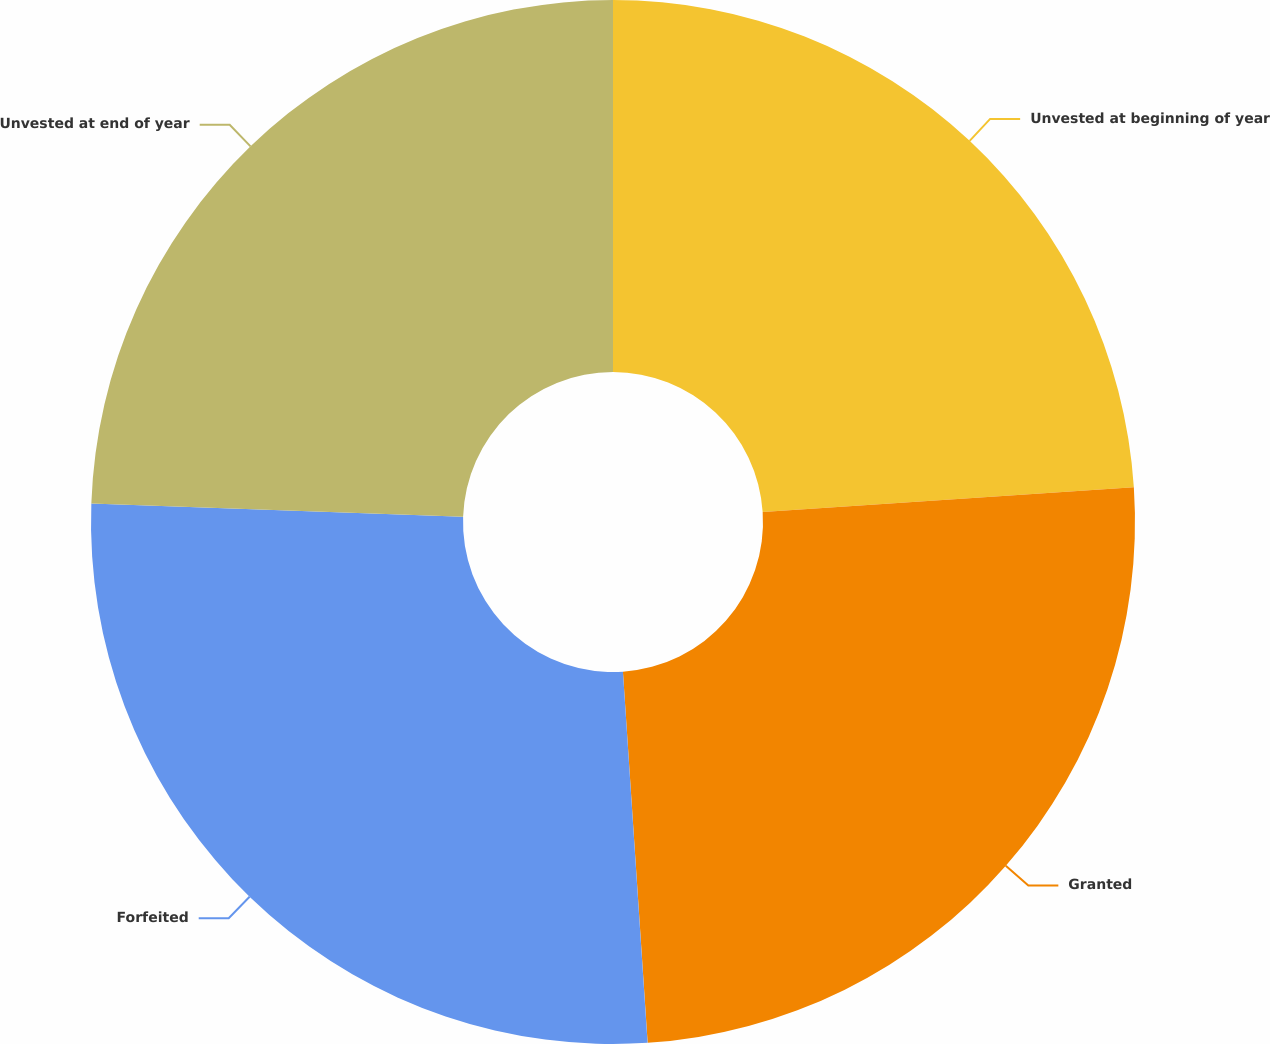Convert chart to OTSL. <chart><loc_0><loc_0><loc_500><loc_500><pie_chart><fcel>Unvested at beginning of year<fcel>Granted<fcel>Forfeited<fcel>Unvested at end of year<nl><fcel>23.94%<fcel>25.0%<fcel>26.62%<fcel>24.43%<nl></chart> 